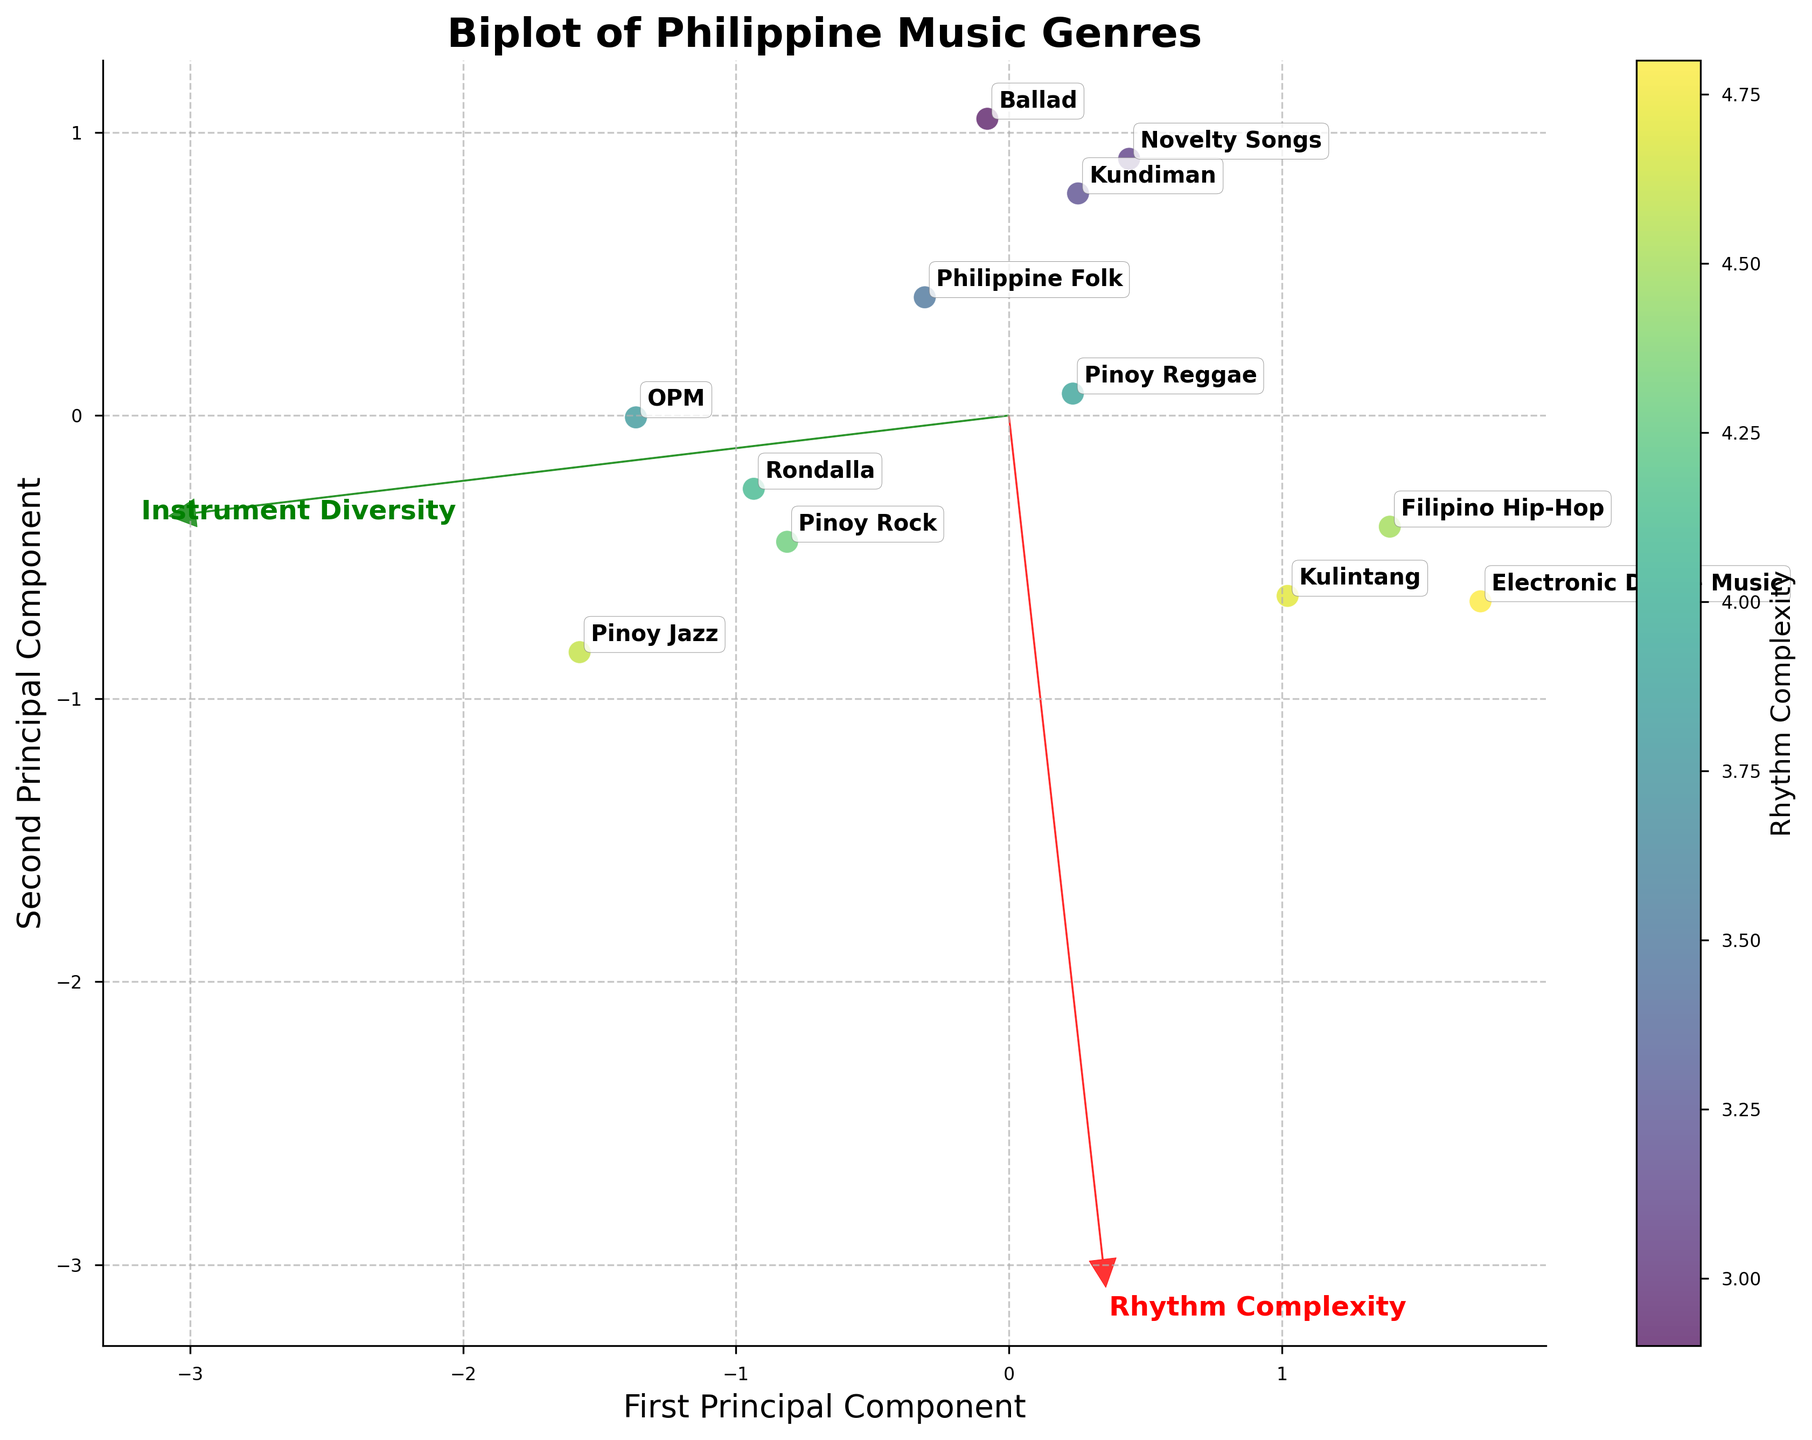What's the title of the plot? The title of the plot is typically located at the top center of the figure. By examining this, one can read and identify the title.
Answer: Biplot of Philippine Music Genres How many principal components are displayed in the figure? A biplot with two input features generally shows two principal components, represented by two axes. They help to visualize the data in reduced dimensions.
Answer: Two Which genre has the least Rhythm Complexity but more Instrument Diversity? Observing the points on the scatter plot, the genre closest to the bottom-left in terms of Rhythm Complexity, yet further right in Instrument Diversity, can be identified.
Answer: Ballad Which genre is closest to the first principal component but low on the second principal component? Examining the scatter points along the first principal component (x-axis), one can spot the genre closest to it and then check if it has a low second principal component (y-axis) value.
Answer: Electronic Dance Music Is Pinoy Jazz closer to Rhythm Complexity or Instrument Diversity? Pinoy Jazz's proximity to the arrows representing features can be visually assessed by checking its position relative to the vectors.
Answer: Instrument Diversity Which genre has a higher Rhythm Complexity: Novelty Songs or Ballad? Compare the positions of Novelty Songs and Ballad points on the first principal component axis (x-axis) to determine which is higher.
Answer: Novelty Songs Is Philippine Folk music closer to Electronic Dance Music or Kundiman in terms of principal components? By visually comparing the distances between Philippine Folk music's point and the points for Electronic Dance Music and Kundiman in the biplot, the closer genre can be determined.
Answer: Kundiman What can you say about the relationship between Rhythm Complexity and Instrument Diversity based on the feature vectors? The angles and directions of the vectors relative to each other can be examined. If they are close to orthogonal, it suggests independence; otherwise, we infer a relationship.
Answer: The two features are moderately related Which genre exhibits the highest combination of Rhythm Complexity and Instrument Diversity? By identifying the genre point furthest from the origin along both principal components, taking into account both axes, the genre with the highest combination can be found.
Answer: Pinoy Jazz How do Philippine Folk music and Pinoy Rock compare in terms of Instrument Diversity? Locate the points for these genres and compare their positions on the second principal component axis (y-axis) to determine which is higher.
Answer: Pinoy Rock 